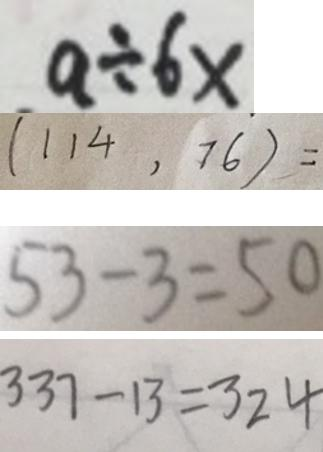Convert formula to latex. <formula><loc_0><loc_0><loc_500><loc_500>a \div 6 x 
 ( 1 1 4 , 7 6 ) = 
 5 3 - 3 = 5 0 
 3 3 7 - 1 3 = 3 2 4</formula> 